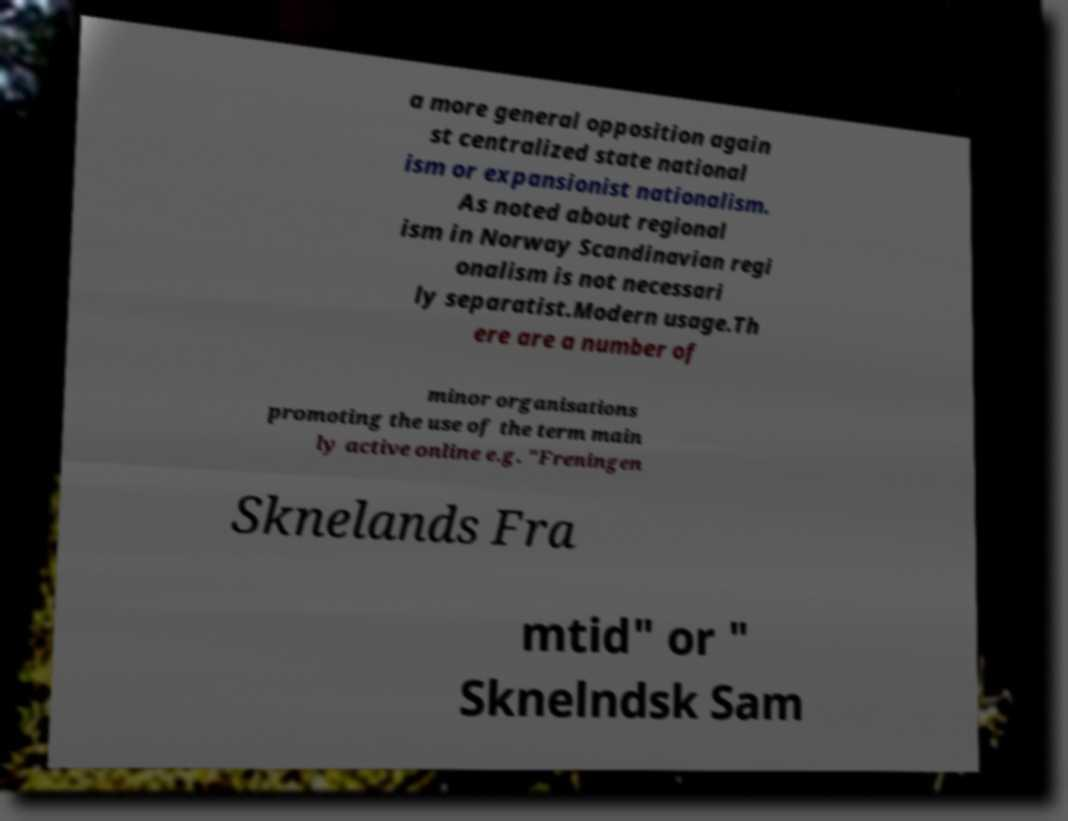There's text embedded in this image that I need extracted. Can you transcribe it verbatim? a more general opposition again st centralized state national ism or expansionist nationalism. As noted about regional ism in Norway Scandinavian regi onalism is not necessari ly separatist.Modern usage.Th ere are a number of minor organisations promoting the use of the term main ly active online e.g. "Freningen Sknelands Fra mtid" or " Sknelndsk Sam 